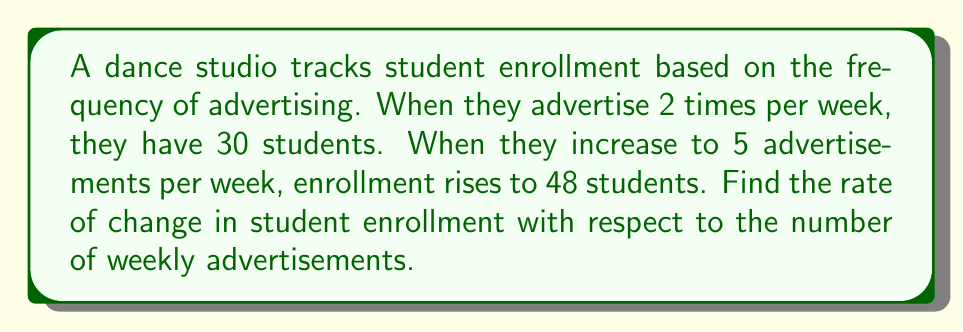Can you solve this math problem? To find the rate of change, we need to calculate the slope of the line between these two points.

1. Identify the two points:
   Point 1: (2 ads/week, 30 students)
   Point 2: (5 ads/week, 48 students)

2. Use the slope formula:
   $$m = \frac{y_2 - y_1}{x_2 - x_1}$$

   Where:
   $x_1 = 2$, $y_1 = 30$
   $x_2 = 5$, $y_2 = 48$

3. Plug in the values:
   $$m = \frac{48 - 30}{5 - 2} = \frac{18}{3}$$

4. Simplify:
   $$m = 6$$

This means that for each additional advertisement per week, the studio gains an average of 6 new students.
Answer: 6 students per ad per week 